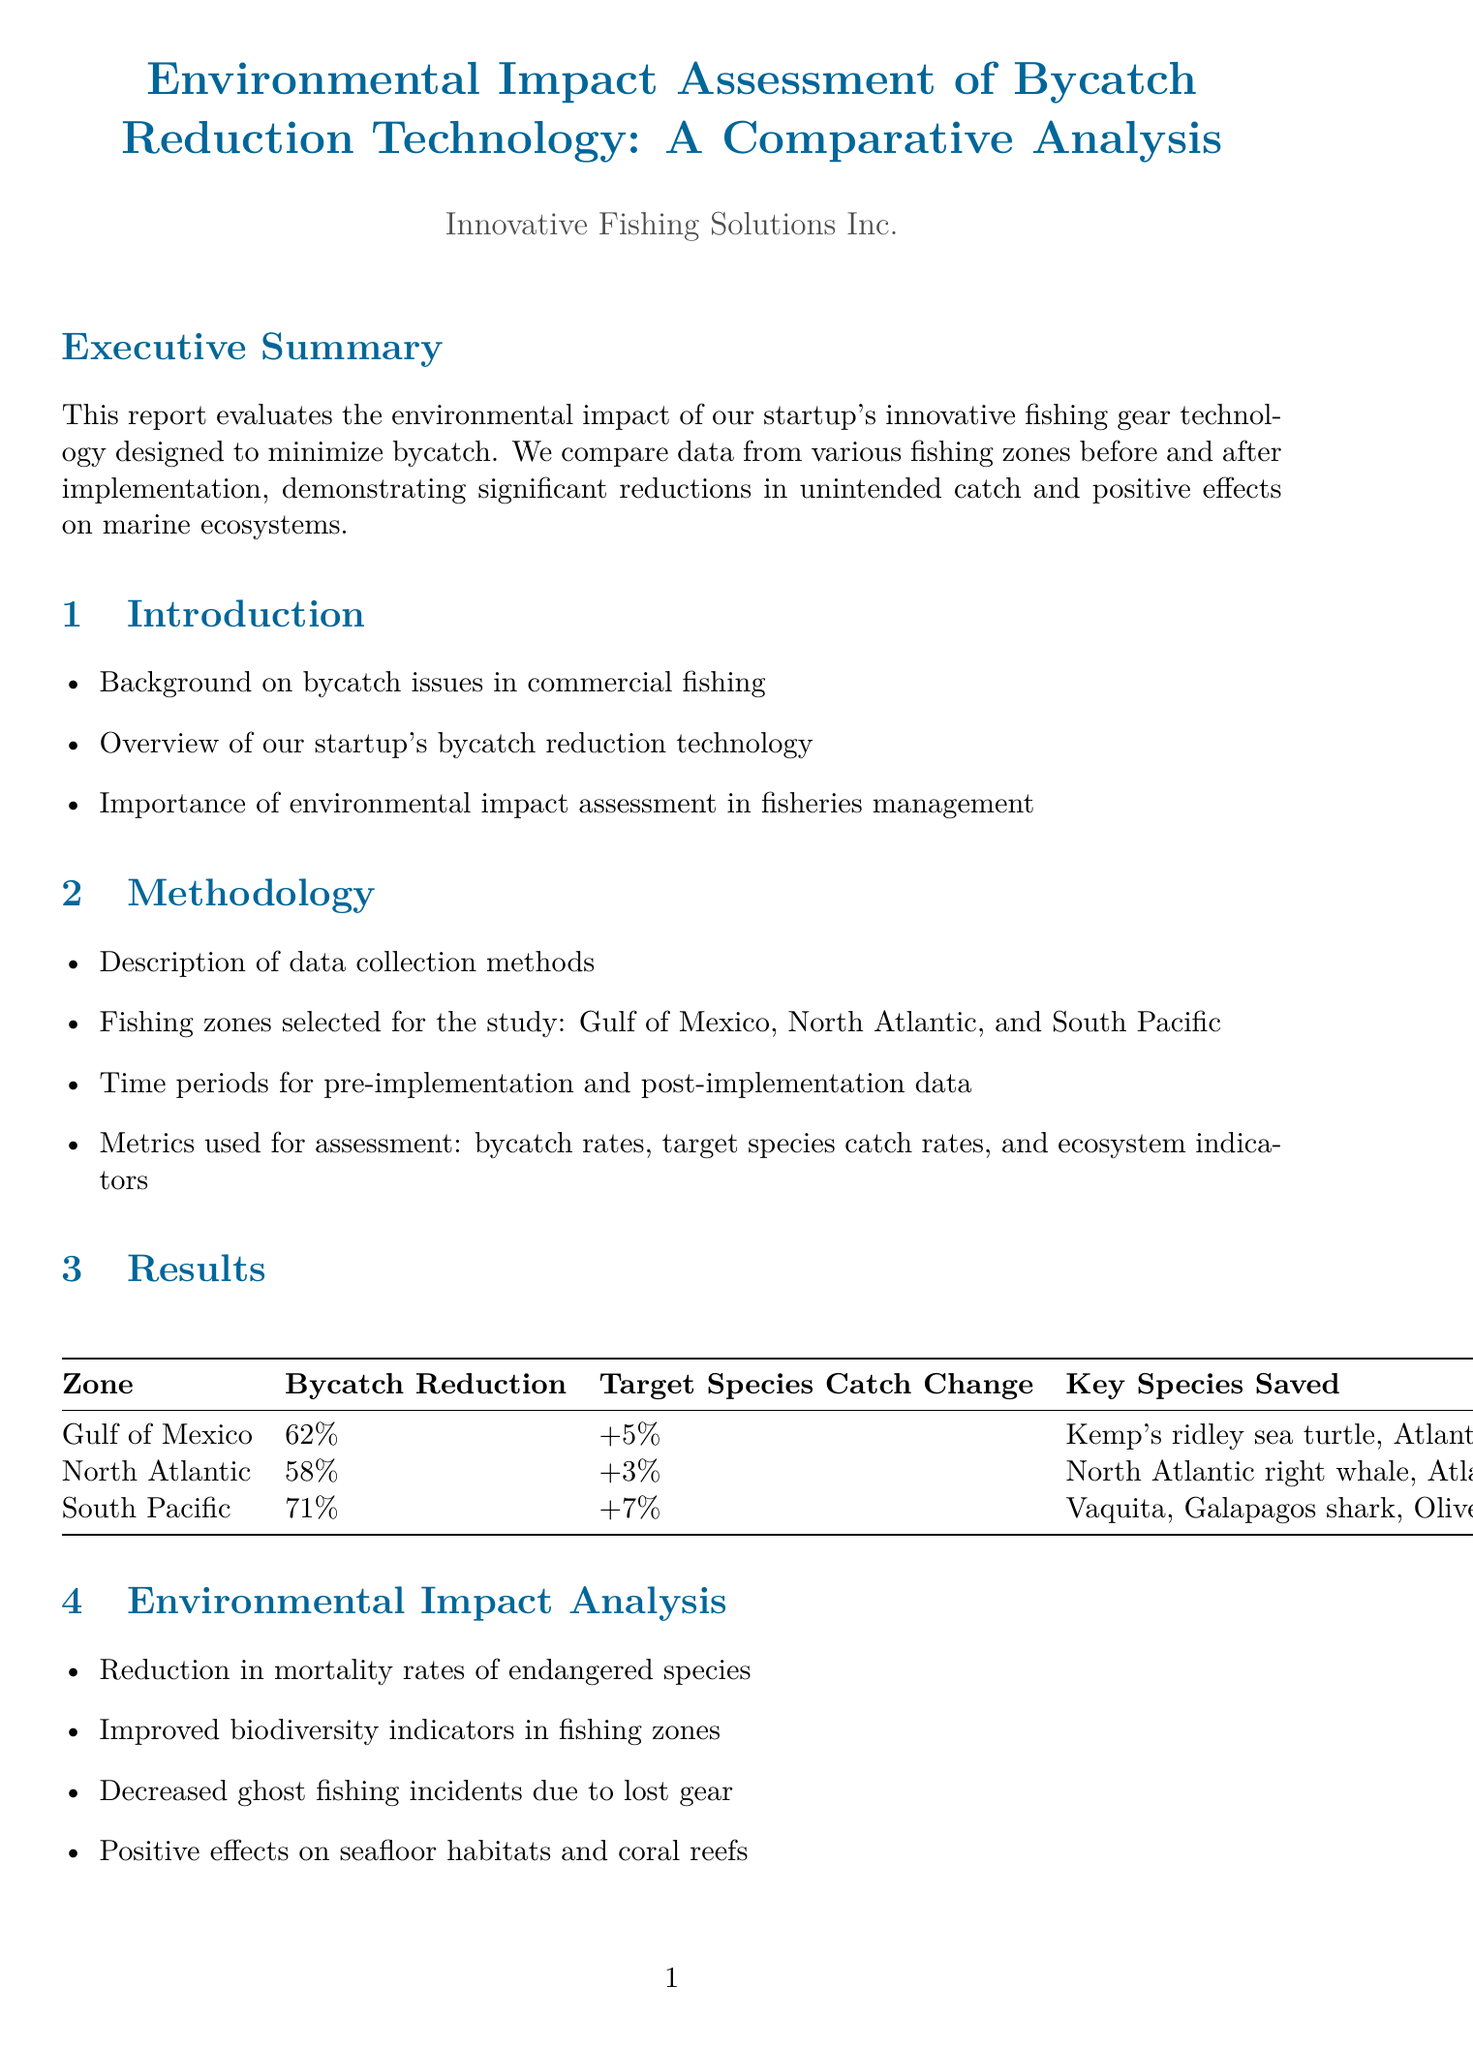what is the bycatch reduction percentage in the Gulf of Mexico? The document states that the bycatch reduction in the Gulf of Mexico is 62%.
Answer: 62% which key species were saved in the South Pacific? The key species saved in the South Pacific listed in the document are Vaquita, Galapagos shark, and Olive ridley sea turtle.
Answer: Vaquita, Galapagos shark, Olive ridley sea turtle what type of economic benefit is mentioned in relation to fuel consumption? The document mentions reduced fuel consumption as an economic implication of the technology.
Answer: Reduced fuel consumption how many companies are featured in the case studies? The document includes three companies featured in the case studies, each demonstrating different results of the bycatch reduction technology.
Answer: Three what is the target species catch change in the North Atlantic? The target species catch change in the North Atlantic is mentioned as an increase of 3%.
Answer: +3% what is the title of Appendix B? The title of Appendix B in the document is "Technical Specifications of Bycatch Reduction Technology."
Answer: Technical Specifications of Bycatch Reduction Technology which fishing zone had the highest bycatch reduction? According to the report, the South Pacific had the highest bycatch reduction of 71%.
Answer: 71% what future development involves AI? The document discusses the integration of AI and machine learning for real-time bycatch prediction as a future development.
Answer: Integration of AI and machine learning for real-time bycatch prediction 